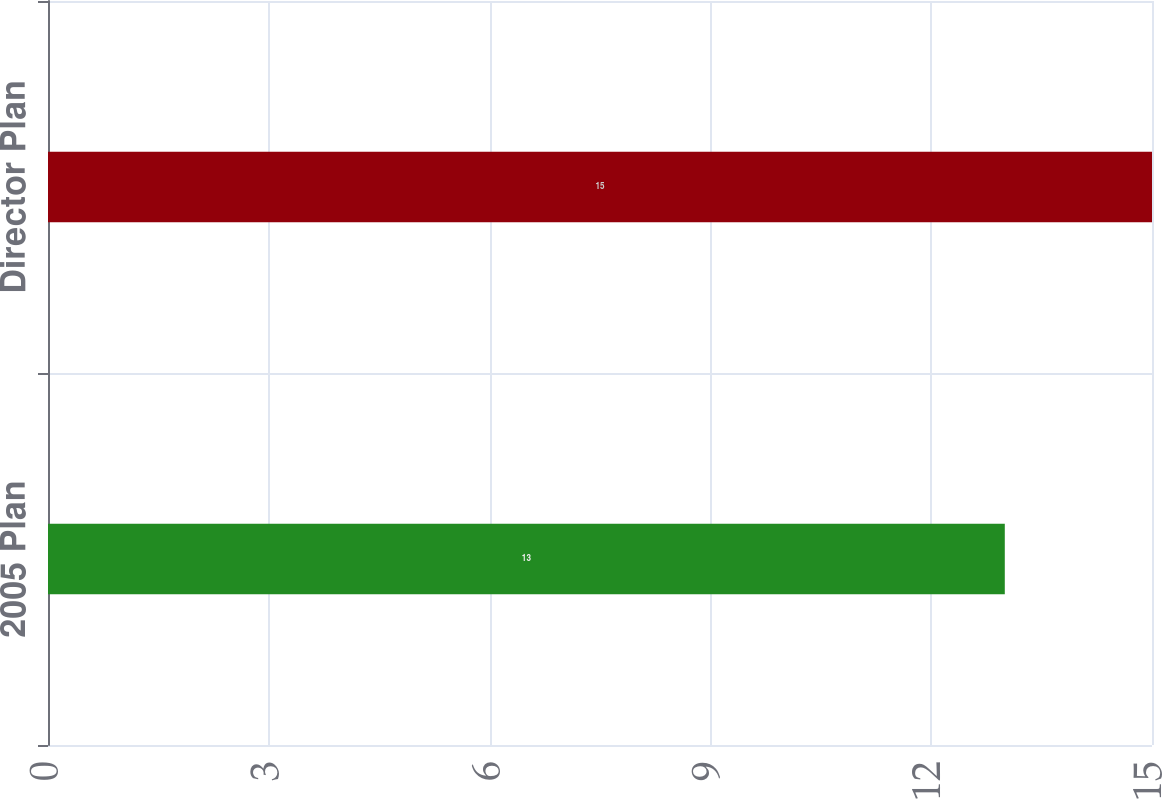<chart> <loc_0><loc_0><loc_500><loc_500><bar_chart><fcel>2005 Plan<fcel>Director Plan<nl><fcel>13<fcel>15<nl></chart> 